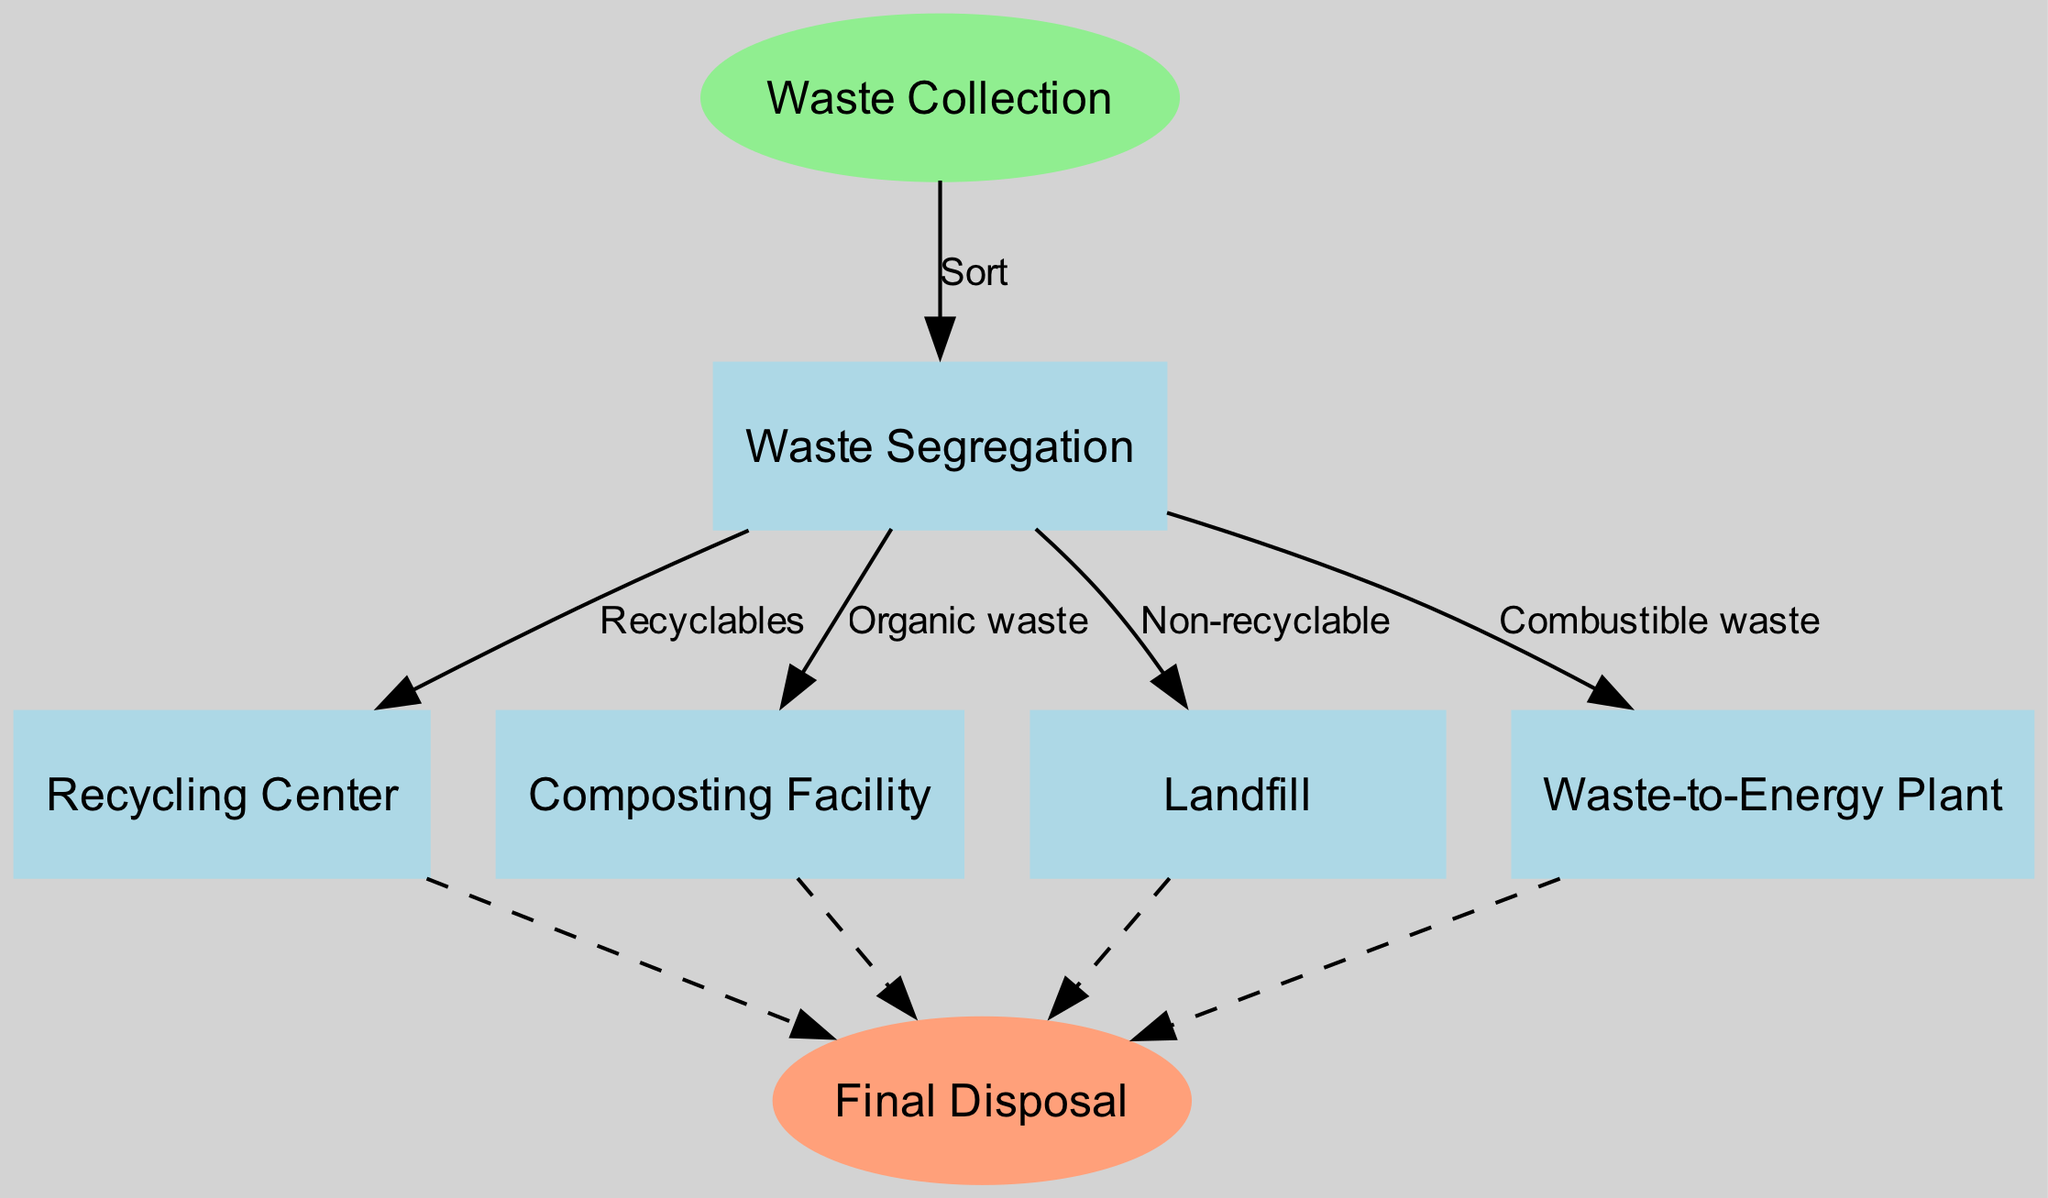What is the starting point of the waste management process? The starting point is indicated at the top of the diagram. It categorically states "Waste Collection" as the first step.
Answer: Waste Collection How many nodes are in the diagram? By counting all the individual steps or locations represented, including both the start and the end, there are a total of six nodes present in the diagram.
Answer: 6 Which node receives organic waste? The arrow from "Waste Segregation" labeled "Organic waste" points directly to the "Composting Facility," indicating that this is where organic waste is directed.
Answer: Composting Facility What is the final disposal point? The end node is specified at the bottom of the diagram as "Final Disposal," indicating where all processes lead to at the conclusion of the waste management sequence.
Answer: Final Disposal Which process handles non-recyclable waste? The diagram has an edge going from "Waste Segregation" to "Landfill" labeled "Non-recyclable," indicating that non-recyclable waste is managed at this node.
Answer: Landfill How many outgoing edges are there from the "Waste Segregation" node? By reviewing the connections from "Waste Segregation," we observe that there are four outgoing edges, leading to the Recycling Center, Composting Facility, Landfill, and Waste-to-Energy Plant.
Answer: 4 What type of waste goes to the "Waste-to-Energy Plant"? The edge from "Waste Segregation" to "Waste-to-Energy Plant" is labeled "Combustible waste," clearly defining what type of waste is directed to this facility.
Answer: Combustible waste Which node does not lead directly to the final disposal? The "Waste Segregation" node does not lead directly to final disposal as it branches out to four other nodes instead. All other nodes lead to final disposal.
Answer: Waste Segregation Which nodes are the end points of the diagram? The end nodes, which culminate the process in the diagram, are indicated as "Recycling Center," "Composting Facility," "Landfill," and "Waste-to-Energy Plant," all ultimately leading to "Final Disposal."
Answer: Recycling Center, Composting Facility, Landfill, Waste-to-Energy Plant 